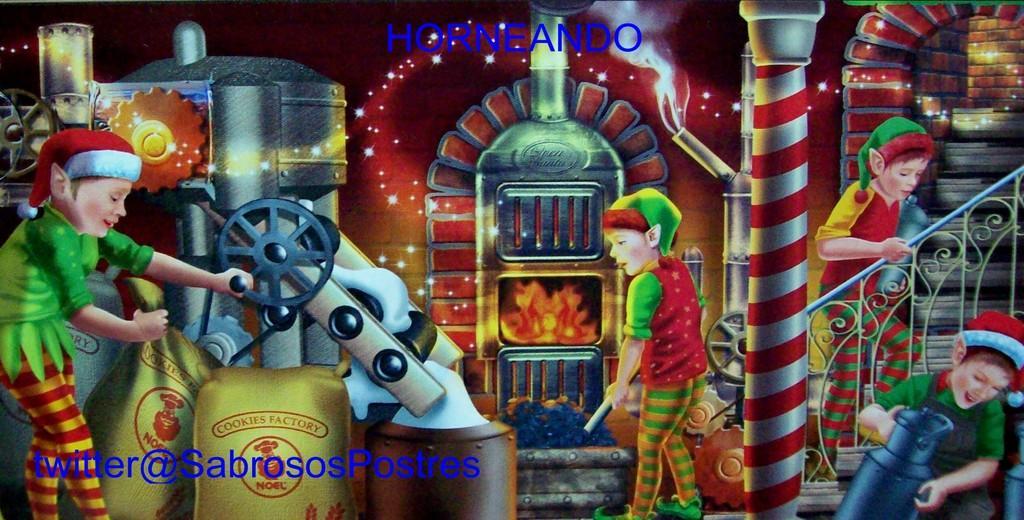Could you give a brief overview of what you see in this image? In this image I can see few people holding something. I can see a machine,bags,poles,stairs. They are in different color. 